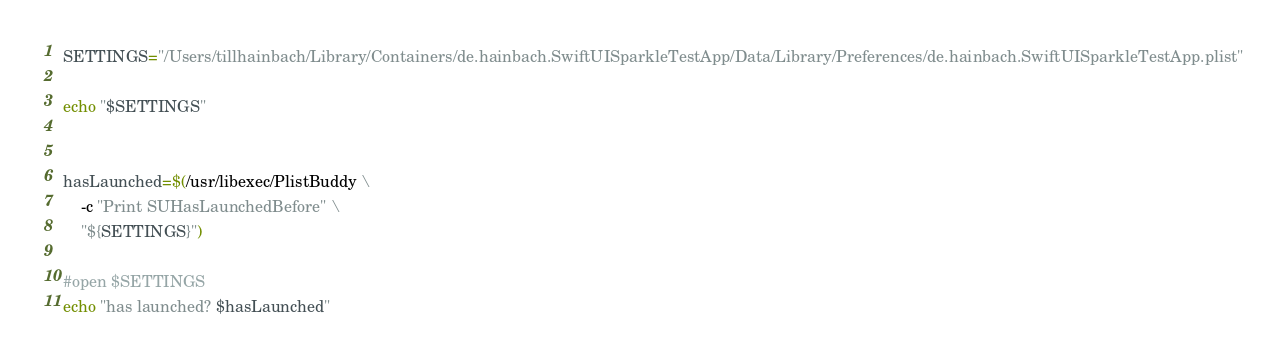<code> <loc_0><loc_0><loc_500><loc_500><_Bash_>SETTINGS="/Users/tillhainbach/Library/Containers/de.hainbach.SwiftUISparkleTestApp/Data/Library/Preferences/de.hainbach.SwiftUISparkleTestApp.plist"

echo "$SETTINGS"


hasLaunched=$(/usr/libexec/PlistBuddy \
    -c "Print SUHasLaunchedBefore" \
    "${SETTINGS}")

#open $SETTINGS
echo "has launched? $hasLaunched"

</code> 